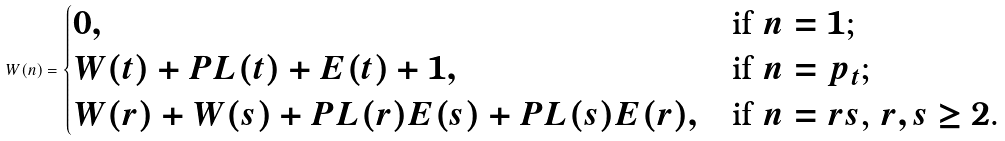Convert formula to latex. <formula><loc_0><loc_0><loc_500><loc_500>W ( n ) = \begin{cases} 0 , & \text {if $n=1$;} \\ W ( t ) + P L ( t ) + E ( t ) + 1 , & \text {if $n=p_{t}$;} \\ W ( r ) + W ( s ) + P L ( r ) E ( s ) + P L ( s ) E ( r ) , & \text {if $n=rs$, $r,s \geq 2$.} \end{cases}</formula> 